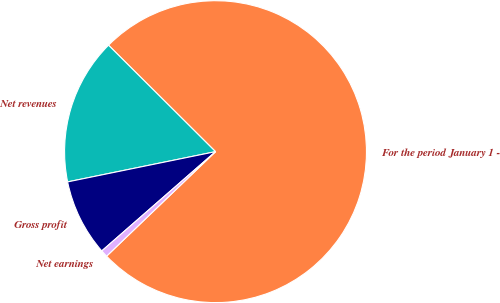<chart> <loc_0><loc_0><loc_500><loc_500><pie_chart><fcel>For the period January 1 -<fcel>Net revenues<fcel>Gross profit<fcel>Net earnings<nl><fcel>75.36%<fcel>15.67%<fcel>8.21%<fcel>0.75%<nl></chart> 